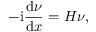<formula> <loc_0><loc_0><loc_500><loc_500>- i \frac { d \nu } { d x } = H \nu ,</formula> 